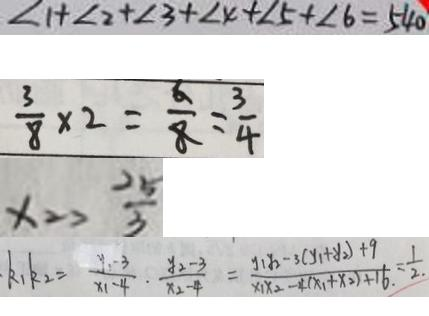<formula> <loc_0><loc_0><loc_500><loc_500>\angle 1 + \angle 2 + \angle 3 + \angle 4 + \angle 5 + \angle 6 = 5 4 0 
 \frac { 3 } { 8 } \times 2 = \frac { 6 } { 8 } = \frac { 3 } { 4 } 
 x _ { 2 } > \frac { 2 5 } { 3 } 
 k _ { 1 } k _ { 2 } = \frac { y _ { 1 } - 3 } { x _ { 1 } - 4 } \cdot \frac { y _ { 2 } - 3 } { x _ { 2 } - 4 } = \frac { y _ { 1 } y _ { 2 } - 3 ( y _ { 1 } + y _ { 2 } ) + 9 } { x _ { 1 } x _ { 2 } - 4 ( x _ { 1 } + x _ { 2 } ) + 1 6 } = \frac { 1 } { 2 }</formula> 